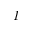Convert formula to latex. <formula><loc_0><loc_0><loc_500><loc_500>I</formula> 